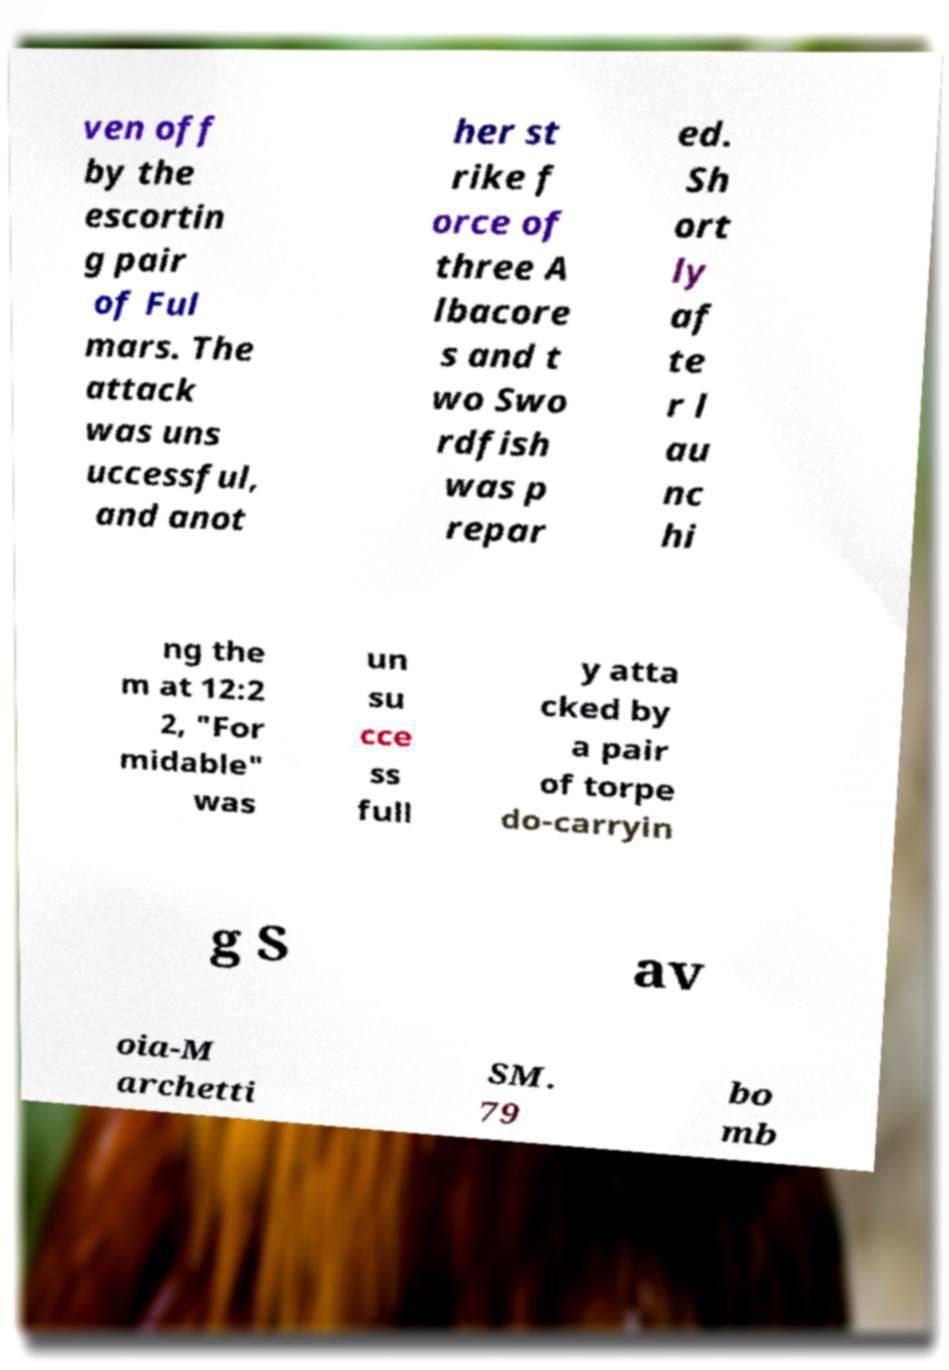I need the written content from this picture converted into text. Can you do that? ven off by the escortin g pair of Ful mars. The attack was uns uccessful, and anot her st rike f orce of three A lbacore s and t wo Swo rdfish was p repar ed. Sh ort ly af te r l au nc hi ng the m at 12:2 2, "For midable" was un su cce ss full y atta cked by a pair of torpe do-carryin g S av oia-M archetti SM. 79 bo mb 